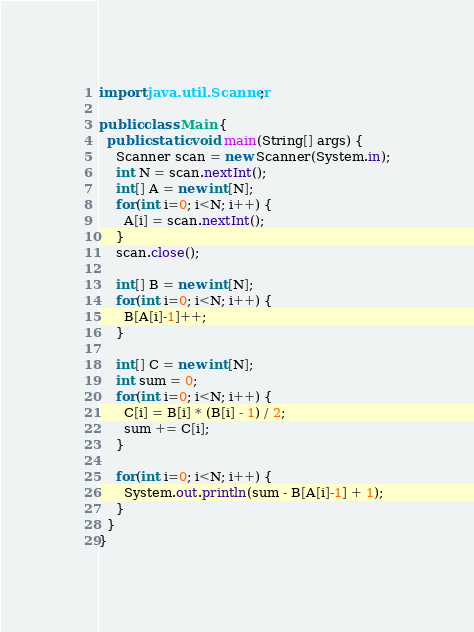<code> <loc_0><loc_0><loc_500><loc_500><_Java_>import java.util.Scanner;

public class Main {
  public static void main(String[] args) {
    Scanner scan = new Scanner(System.in);
    int N = scan.nextInt();
    int[] A = new int[N];
    for(int i=0; i<N; i++) {
      A[i] = scan.nextInt();
    }
    scan.close();

    int[] B = new int[N];
    for(int i=0; i<N; i++) {
      B[A[i]-1]++;
    }

    int[] C = new int[N];
    int sum = 0;
    for(int i=0; i<N; i++) {
      C[i] = B[i] * (B[i] - 1) / 2;
      sum += C[i];
    }

    for(int i=0; i<N; i++) {
      System.out.println(sum - B[A[i]-1] + 1);
    }
  }
}</code> 